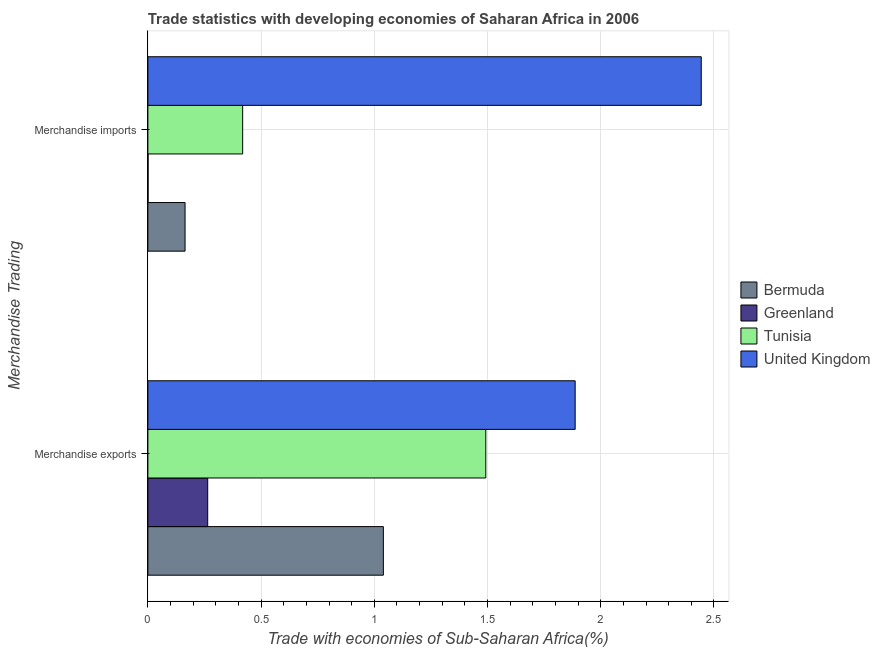How many groups of bars are there?
Your answer should be compact. 2. How many bars are there on the 1st tick from the bottom?
Provide a succinct answer. 4. What is the label of the 1st group of bars from the top?
Provide a short and direct response. Merchandise imports. What is the merchandise exports in United Kingdom?
Your answer should be very brief. 1.89. Across all countries, what is the maximum merchandise imports?
Your answer should be very brief. 2.44. Across all countries, what is the minimum merchandise imports?
Make the answer very short. 0. In which country was the merchandise imports maximum?
Your answer should be very brief. United Kingdom. In which country was the merchandise imports minimum?
Your answer should be compact. Greenland. What is the total merchandise imports in the graph?
Make the answer very short. 3.03. What is the difference between the merchandise exports in Bermuda and that in United Kingdom?
Ensure brevity in your answer.  -0.85. What is the difference between the merchandise imports in Bermuda and the merchandise exports in Tunisia?
Make the answer very short. -1.33. What is the average merchandise imports per country?
Your answer should be very brief. 0.76. What is the difference between the merchandise exports and merchandise imports in Greenland?
Offer a terse response. 0.26. In how many countries, is the merchandise imports greater than 2 %?
Make the answer very short. 1. What is the ratio of the merchandise exports in Greenland to that in Bermuda?
Ensure brevity in your answer.  0.25. In how many countries, is the merchandise imports greater than the average merchandise imports taken over all countries?
Give a very brief answer. 1. What does the 3rd bar from the top in Merchandise exports represents?
Your answer should be compact. Greenland. What does the 1st bar from the bottom in Merchandise exports represents?
Your response must be concise. Bermuda. How many bars are there?
Provide a succinct answer. 8. Are all the bars in the graph horizontal?
Your response must be concise. Yes. Are the values on the major ticks of X-axis written in scientific E-notation?
Keep it short and to the point. No. Does the graph contain grids?
Keep it short and to the point. Yes. How many legend labels are there?
Offer a very short reply. 4. What is the title of the graph?
Your answer should be very brief. Trade statistics with developing economies of Saharan Africa in 2006. What is the label or title of the X-axis?
Provide a succinct answer. Trade with economies of Sub-Saharan Africa(%). What is the label or title of the Y-axis?
Make the answer very short. Merchandise Trading. What is the Trade with economies of Sub-Saharan Africa(%) in Bermuda in Merchandise exports?
Your answer should be very brief. 1.04. What is the Trade with economies of Sub-Saharan Africa(%) in Greenland in Merchandise exports?
Your response must be concise. 0.26. What is the Trade with economies of Sub-Saharan Africa(%) in Tunisia in Merchandise exports?
Offer a terse response. 1.49. What is the Trade with economies of Sub-Saharan Africa(%) in United Kingdom in Merchandise exports?
Your response must be concise. 1.89. What is the Trade with economies of Sub-Saharan Africa(%) of Bermuda in Merchandise imports?
Give a very brief answer. 0.16. What is the Trade with economies of Sub-Saharan Africa(%) of Greenland in Merchandise imports?
Provide a short and direct response. 0. What is the Trade with economies of Sub-Saharan Africa(%) of Tunisia in Merchandise imports?
Provide a succinct answer. 0.42. What is the Trade with economies of Sub-Saharan Africa(%) of United Kingdom in Merchandise imports?
Provide a succinct answer. 2.44. Across all Merchandise Trading, what is the maximum Trade with economies of Sub-Saharan Africa(%) in Bermuda?
Your answer should be compact. 1.04. Across all Merchandise Trading, what is the maximum Trade with economies of Sub-Saharan Africa(%) of Greenland?
Your answer should be very brief. 0.26. Across all Merchandise Trading, what is the maximum Trade with economies of Sub-Saharan Africa(%) in Tunisia?
Offer a very short reply. 1.49. Across all Merchandise Trading, what is the maximum Trade with economies of Sub-Saharan Africa(%) of United Kingdom?
Make the answer very short. 2.44. Across all Merchandise Trading, what is the minimum Trade with economies of Sub-Saharan Africa(%) of Bermuda?
Your answer should be very brief. 0.16. Across all Merchandise Trading, what is the minimum Trade with economies of Sub-Saharan Africa(%) in Greenland?
Keep it short and to the point. 0. Across all Merchandise Trading, what is the minimum Trade with economies of Sub-Saharan Africa(%) in Tunisia?
Offer a terse response. 0.42. Across all Merchandise Trading, what is the minimum Trade with economies of Sub-Saharan Africa(%) in United Kingdom?
Your answer should be compact. 1.89. What is the total Trade with economies of Sub-Saharan Africa(%) in Bermuda in the graph?
Provide a succinct answer. 1.2. What is the total Trade with economies of Sub-Saharan Africa(%) in Greenland in the graph?
Your answer should be very brief. 0.27. What is the total Trade with economies of Sub-Saharan Africa(%) in Tunisia in the graph?
Keep it short and to the point. 1.91. What is the total Trade with economies of Sub-Saharan Africa(%) of United Kingdom in the graph?
Your answer should be compact. 4.33. What is the difference between the Trade with economies of Sub-Saharan Africa(%) in Bermuda in Merchandise exports and that in Merchandise imports?
Give a very brief answer. 0.88. What is the difference between the Trade with economies of Sub-Saharan Africa(%) in Greenland in Merchandise exports and that in Merchandise imports?
Your answer should be very brief. 0.26. What is the difference between the Trade with economies of Sub-Saharan Africa(%) of Tunisia in Merchandise exports and that in Merchandise imports?
Your response must be concise. 1.07. What is the difference between the Trade with economies of Sub-Saharan Africa(%) in United Kingdom in Merchandise exports and that in Merchandise imports?
Offer a terse response. -0.56. What is the difference between the Trade with economies of Sub-Saharan Africa(%) in Bermuda in Merchandise exports and the Trade with economies of Sub-Saharan Africa(%) in Greenland in Merchandise imports?
Provide a short and direct response. 1.04. What is the difference between the Trade with economies of Sub-Saharan Africa(%) of Bermuda in Merchandise exports and the Trade with economies of Sub-Saharan Africa(%) of Tunisia in Merchandise imports?
Ensure brevity in your answer.  0.62. What is the difference between the Trade with economies of Sub-Saharan Africa(%) of Bermuda in Merchandise exports and the Trade with economies of Sub-Saharan Africa(%) of United Kingdom in Merchandise imports?
Provide a short and direct response. -1.4. What is the difference between the Trade with economies of Sub-Saharan Africa(%) of Greenland in Merchandise exports and the Trade with economies of Sub-Saharan Africa(%) of Tunisia in Merchandise imports?
Offer a terse response. -0.15. What is the difference between the Trade with economies of Sub-Saharan Africa(%) in Greenland in Merchandise exports and the Trade with economies of Sub-Saharan Africa(%) in United Kingdom in Merchandise imports?
Keep it short and to the point. -2.18. What is the difference between the Trade with economies of Sub-Saharan Africa(%) of Tunisia in Merchandise exports and the Trade with economies of Sub-Saharan Africa(%) of United Kingdom in Merchandise imports?
Your answer should be very brief. -0.95. What is the average Trade with economies of Sub-Saharan Africa(%) in Bermuda per Merchandise Trading?
Your answer should be very brief. 0.6. What is the average Trade with economies of Sub-Saharan Africa(%) of Greenland per Merchandise Trading?
Ensure brevity in your answer.  0.13. What is the average Trade with economies of Sub-Saharan Africa(%) of Tunisia per Merchandise Trading?
Your answer should be very brief. 0.96. What is the average Trade with economies of Sub-Saharan Africa(%) in United Kingdom per Merchandise Trading?
Your answer should be very brief. 2.17. What is the difference between the Trade with economies of Sub-Saharan Africa(%) in Bermuda and Trade with economies of Sub-Saharan Africa(%) in Greenland in Merchandise exports?
Provide a succinct answer. 0.78. What is the difference between the Trade with economies of Sub-Saharan Africa(%) of Bermuda and Trade with economies of Sub-Saharan Africa(%) of Tunisia in Merchandise exports?
Ensure brevity in your answer.  -0.45. What is the difference between the Trade with economies of Sub-Saharan Africa(%) of Bermuda and Trade with economies of Sub-Saharan Africa(%) of United Kingdom in Merchandise exports?
Your answer should be very brief. -0.85. What is the difference between the Trade with economies of Sub-Saharan Africa(%) in Greenland and Trade with economies of Sub-Saharan Africa(%) in Tunisia in Merchandise exports?
Make the answer very short. -1.23. What is the difference between the Trade with economies of Sub-Saharan Africa(%) in Greenland and Trade with economies of Sub-Saharan Africa(%) in United Kingdom in Merchandise exports?
Ensure brevity in your answer.  -1.62. What is the difference between the Trade with economies of Sub-Saharan Africa(%) of Tunisia and Trade with economies of Sub-Saharan Africa(%) of United Kingdom in Merchandise exports?
Give a very brief answer. -0.39. What is the difference between the Trade with economies of Sub-Saharan Africa(%) of Bermuda and Trade with economies of Sub-Saharan Africa(%) of Greenland in Merchandise imports?
Provide a short and direct response. 0.16. What is the difference between the Trade with economies of Sub-Saharan Africa(%) of Bermuda and Trade with economies of Sub-Saharan Africa(%) of Tunisia in Merchandise imports?
Your answer should be compact. -0.25. What is the difference between the Trade with economies of Sub-Saharan Africa(%) of Bermuda and Trade with economies of Sub-Saharan Africa(%) of United Kingdom in Merchandise imports?
Give a very brief answer. -2.28. What is the difference between the Trade with economies of Sub-Saharan Africa(%) of Greenland and Trade with economies of Sub-Saharan Africa(%) of Tunisia in Merchandise imports?
Provide a succinct answer. -0.42. What is the difference between the Trade with economies of Sub-Saharan Africa(%) of Greenland and Trade with economies of Sub-Saharan Africa(%) of United Kingdom in Merchandise imports?
Keep it short and to the point. -2.44. What is the difference between the Trade with economies of Sub-Saharan Africa(%) of Tunisia and Trade with economies of Sub-Saharan Africa(%) of United Kingdom in Merchandise imports?
Ensure brevity in your answer.  -2.03. What is the ratio of the Trade with economies of Sub-Saharan Africa(%) in Bermuda in Merchandise exports to that in Merchandise imports?
Provide a short and direct response. 6.33. What is the ratio of the Trade with economies of Sub-Saharan Africa(%) in Greenland in Merchandise exports to that in Merchandise imports?
Provide a succinct answer. 303.77. What is the ratio of the Trade with economies of Sub-Saharan Africa(%) in Tunisia in Merchandise exports to that in Merchandise imports?
Offer a terse response. 3.56. What is the ratio of the Trade with economies of Sub-Saharan Africa(%) of United Kingdom in Merchandise exports to that in Merchandise imports?
Ensure brevity in your answer.  0.77. What is the difference between the highest and the second highest Trade with economies of Sub-Saharan Africa(%) of Bermuda?
Your response must be concise. 0.88. What is the difference between the highest and the second highest Trade with economies of Sub-Saharan Africa(%) of Greenland?
Keep it short and to the point. 0.26. What is the difference between the highest and the second highest Trade with economies of Sub-Saharan Africa(%) in Tunisia?
Give a very brief answer. 1.07. What is the difference between the highest and the second highest Trade with economies of Sub-Saharan Africa(%) of United Kingdom?
Offer a terse response. 0.56. What is the difference between the highest and the lowest Trade with economies of Sub-Saharan Africa(%) in Bermuda?
Make the answer very short. 0.88. What is the difference between the highest and the lowest Trade with economies of Sub-Saharan Africa(%) in Greenland?
Offer a terse response. 0.26. What is the difference between the highest and the lowest Trade with economies of Sub-Saharan Africa(%) in Tunisia?
Your answer should be compact. 1.07. What is the difference between the highest and the lowest Trade with economies of Sub-Saharan Africa(%) of United Kingdom?
Provide a short and direct response. 0.56. 